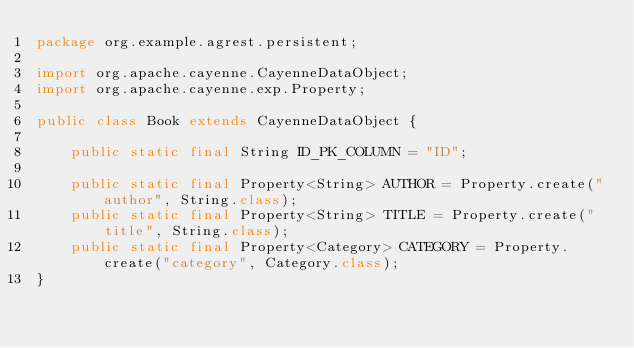Convert code to text. <code><loc_0><loc_0><loc_500><loc_500><_Java_>package org.example.agrest.persistent;

import org.apache.cayenne.CayenneDataObject;
import org.apache.cayenne.exp.Property;

public class Book extends CayenneDataObject {

    public static final String ID_PK_COLUMN = "ID";

    public static final Property<String> AUTHOR = Property.create("author", String.class);
    public static final Property<String> TITLE = Property.create("title", String.class);
    public static final Property<Category> CATEGORY = Property.create("category", Category.class);
}
</code> 